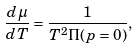<formula> <loc_0><loc_0><loc_500><loc_500>\frac { d \mu } { d T } = \frac { 1 } { T ^ { 2 } \Pi ( p = 0 ) } ,</formula> 